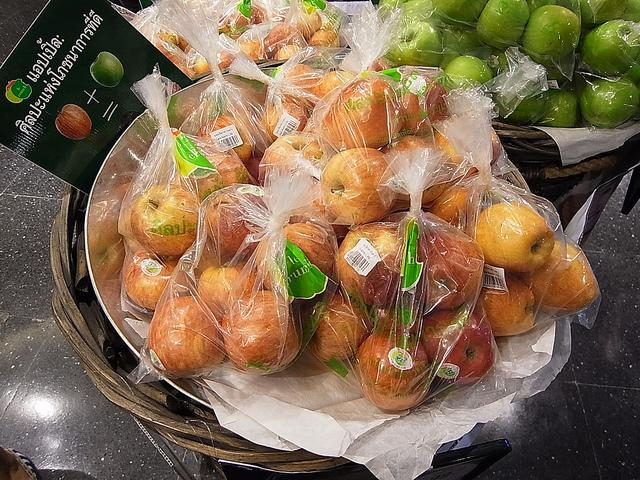What is the condition of these items? good 